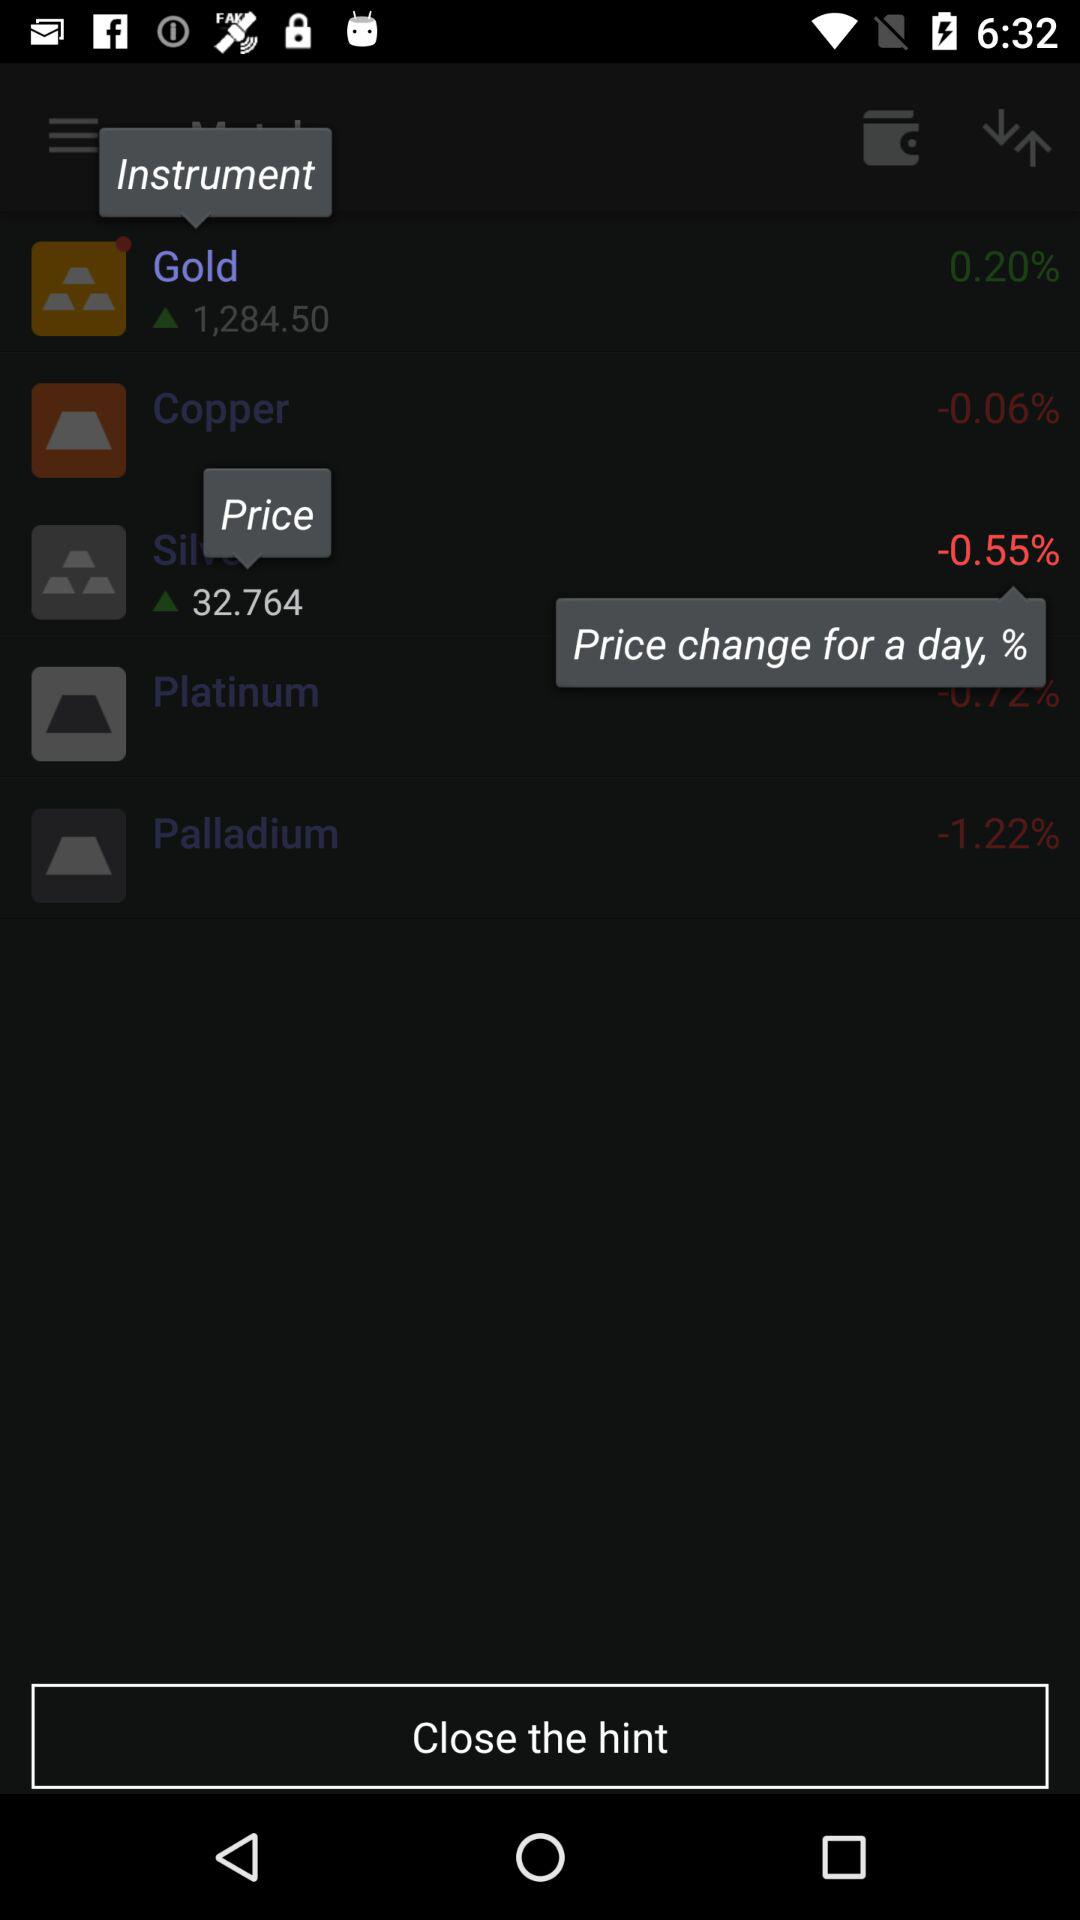Which metal is up more than 0.5%?
Answer the question using a single word or phrase. Gold 